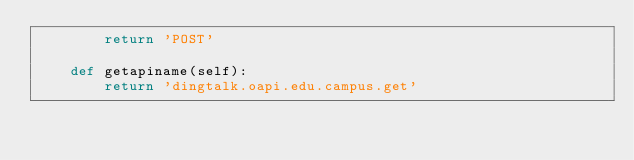Convert code to text. <code><loc_0><loc_0><loc_500><loc_500><_Python_>		return 'POST'

	def getapiname(self):
		return 'dingtalk.oapi.edu.campus.get'
</code> 